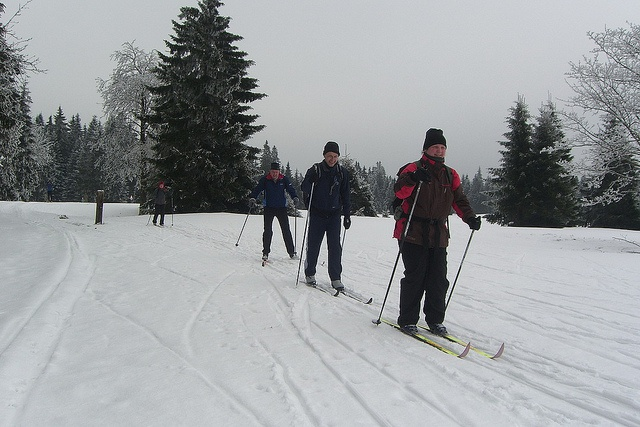Describe the objects in this image and their specific colors. I can see people in darkgray, black, maroon, gray, and lightgray tones, people in darkgray, black, gray, and lightgray tones, people in darkgray, black, gray, and lightgray tones, skis in darkgray, gray, black, and tan tones, and people in darkgray, black, gray, and maroon tones in this image. 